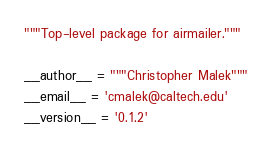<code> <loc_0><loc_0><loc_500><loc_500><_Python_>"""Top-level package for airmailer."""

__author__ = """Christopher Malek"""
__email__ = 'cmalek@caltech.edu'
__version__ = '0.1.2'
</code> 